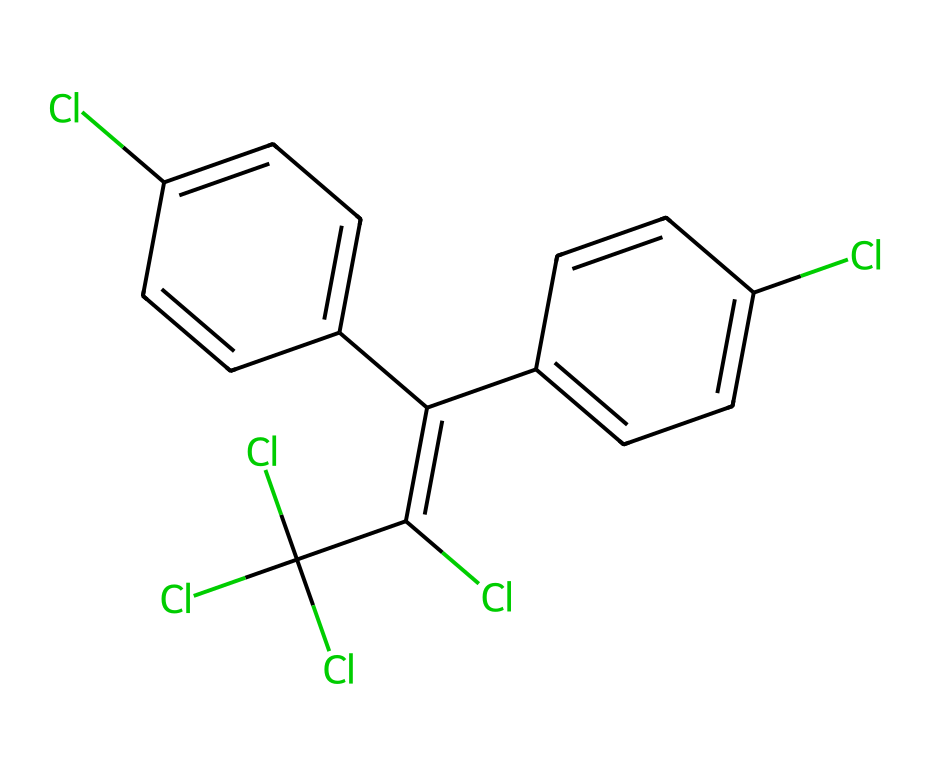How many chlorine atoms are present in this chemical? By examining the SMILES representation, we can count the chlorine (Cl) atoms. The structure includes the Cl symbols multiple times, specifically four occurrences throughout the molecule.
Answer: 4 What is the base structure of this chemical? The chemical structure represents DDT, which is a chlorinated hydrocarbon pesticide. Identifying the connectivity of the carbons and functional groups indicates that it is primarily comprised of benzene rings with chlorine substituents.
Answer: DDT How many rings are present in this chemical structure? The SMILES shows two distinct benzene rings that are part of the overall structure. Each ring contributes to the stability and hydrophobic nature of the pesticide. Counting each ring gives us a total of two.
Answer: 2 What type of chemical bonds predominantly exist in this structure? Upon analyzing the connections in the SMILES, we observe that the molecule primarily contains carbon-carbon (C-C) and carbon-chlorine (C-Cl) single and double bonds, particularly in the aromatic rings, characterizing the compound as a halogenated organic molecule.
Answer: C-C and C-Cl Does this chemical decompose easily in the environment? Due to the presence of persistent chlorine atoms and stable carbon frameworks, DDT is known to be highly resistant to environmental degradation, leading to bioaccumulation in ecosystems. This resistance primarily relates to its stable chemical bonds and structure.
Answer: No 